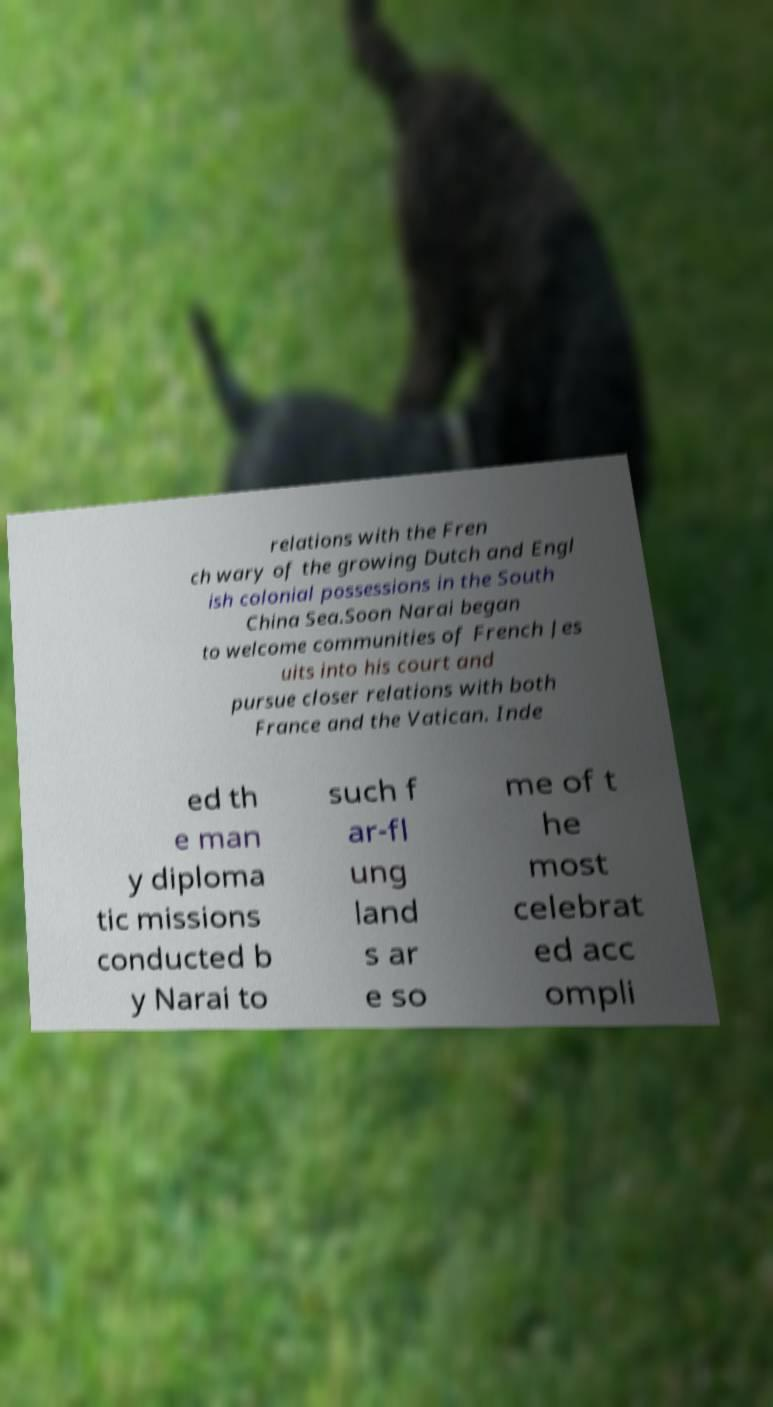Please read and relay the text visible in this image. What does it say? relations with the Fren ch wary of the growing Dutch and Engl ish colonial possessions in the South China Sea.Soon Narai began to welcome communities of French Jes uits into his court and pursue closer relations with both France and the Vatican. Inde ed th e man y diploma tic missions conducted b y Narai to such f ar-fl ung land s ar e so me of t he most celebrat ed acc ompli 